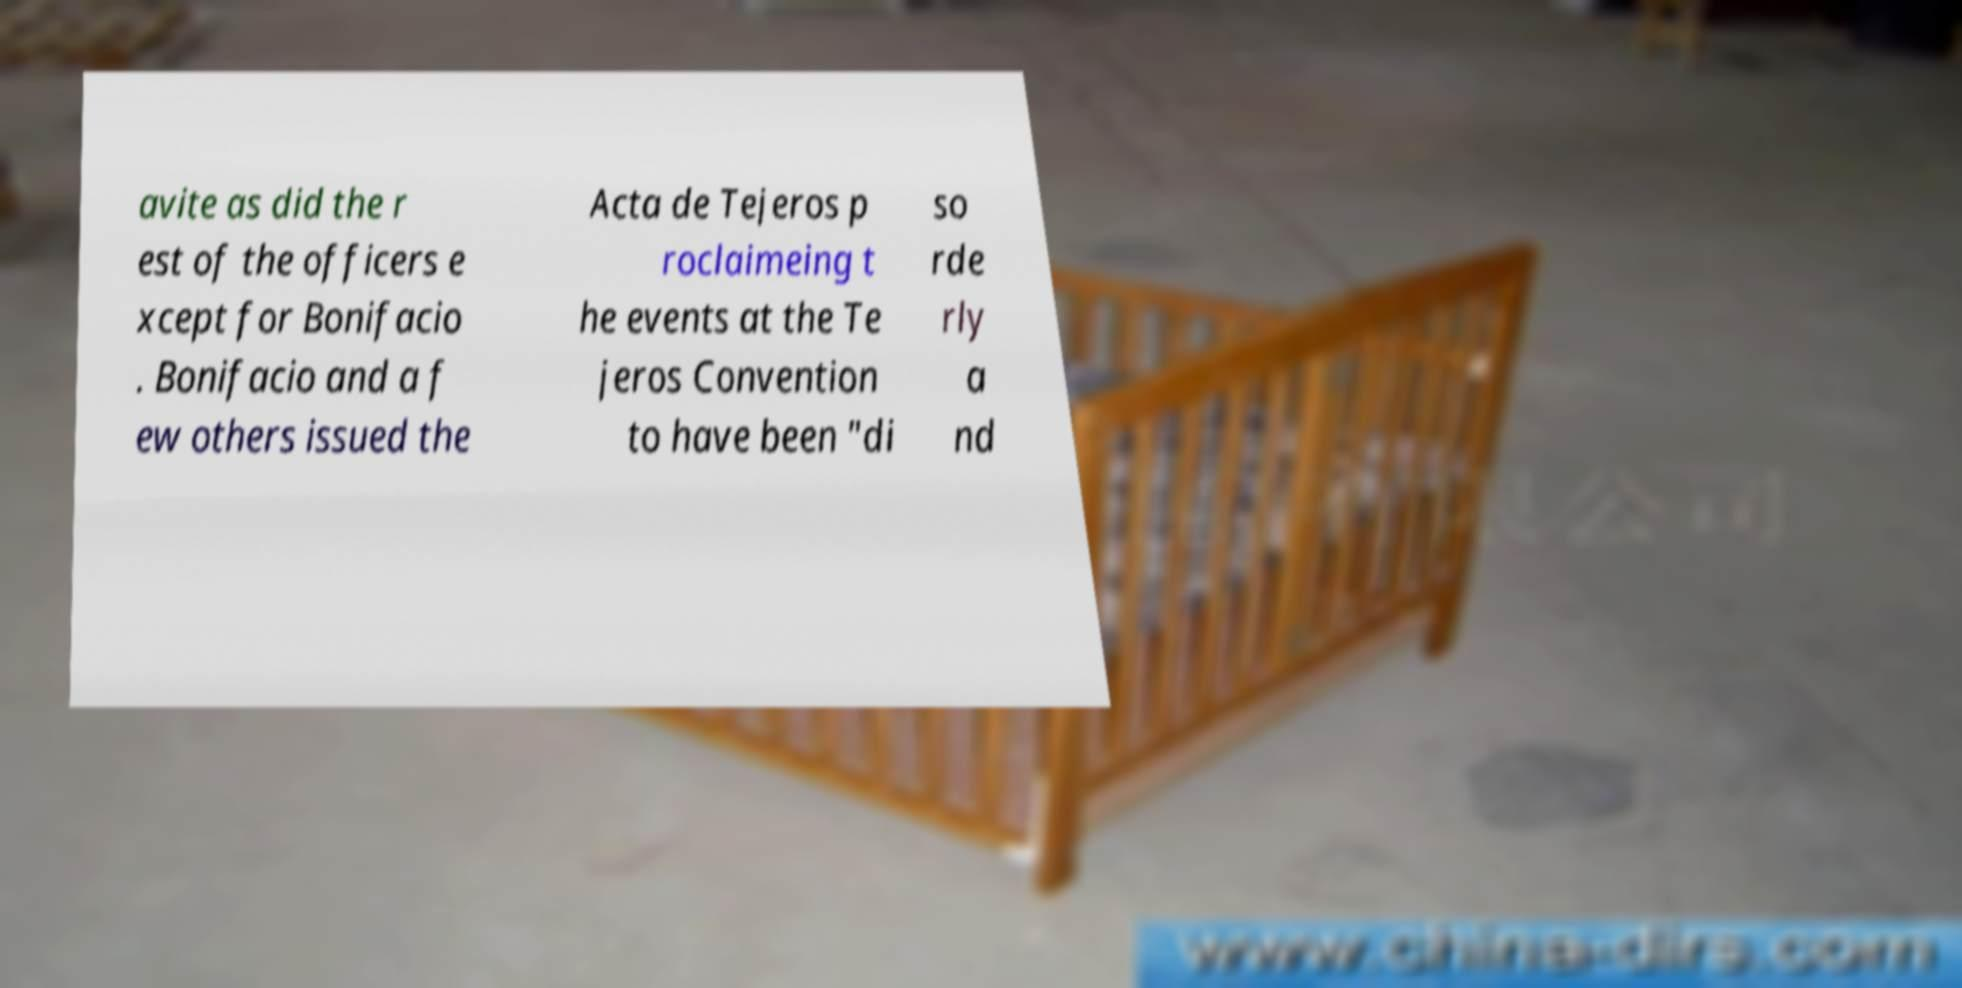For documentation purposes, I need the text within this image transcribed. Could you provide that? avite as did the r est of the officers e xcept for Bonifacio . Bonifacio and a f ew others issued the Acta de Tejeros p roclaimeing t he events at the Te jeros Convention to have been "di so rde rly a nd 